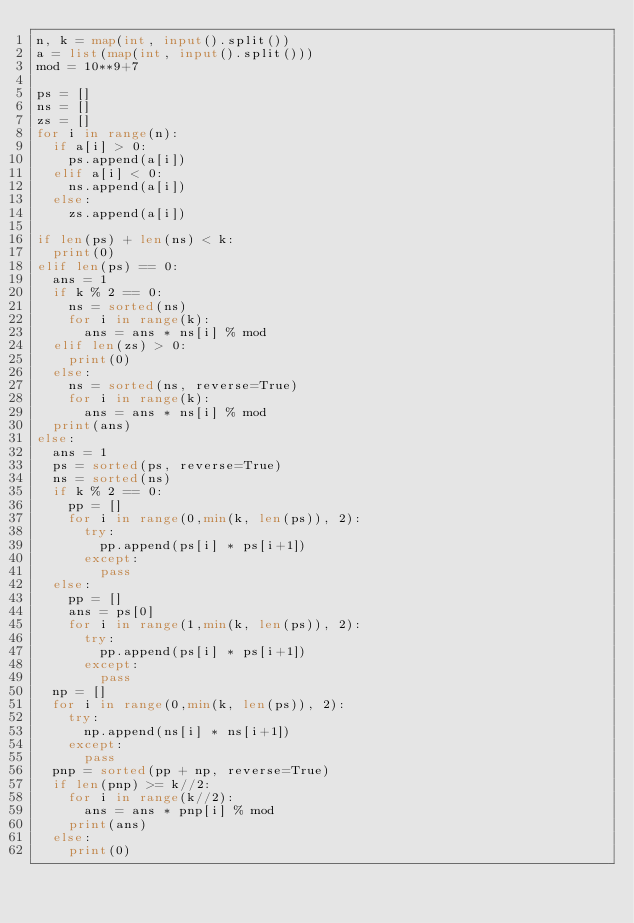Convert code to text. <code><loc_0><loc_0><loc_500><loc_500><_Python_>n, k = map(int, input().split())
a = list(map(int, input().split()))
mod = 10**9+7

ps = []
ns = []
zs = []
for i in range(n):
  if a[i] > 0:
    ps.append(a[i])
  elif a[i] < 0:
    ns.append(a[i])
  else:
    zs.append(a[i])
    
if len(ps) + len(ns) < k:
  print(0)
elif len(ps) == 0:
  ans = 1
  if k % 2 == 0:
    ns = sorted(ns)
    for i in range(k):
      ans = ans * ns[i] % mod
  elif len(zs) > 0:
    print(0)
  else:
    ns = sorted(ns, reverse=True)
    for i in range(k):
      ans = ans * ns[i] % mod
  print(ans)
else:
  ans = 1
  ps = sorted(ps, reverse=True)
  ns = sorted(ns)
  if k % 2 == 0:
    pp = []
    for i in range(0,min(k, len(ps)), 2):
      try:
        pp.append(ps[i] * ps[i+1])
      except:
        pass
  else:
    pp = []
    ans = ps[0]
    for i in range(1,min(k, len(ps)), 2):
      try:
        pp.append(ps[i] * ps[i+1])
      except:
        pass
  np = []
  for i in range(0,min(k, len(ps)), 2):
    try:
      np.append(ns[i] * ns[i+1])
    except:
      pass
  pnp = sorted(pp + np, reverse=True)
  if len(pnp) >= k//2:
    for i in range(k//2):
      ans = ans * pnp[i] % mod
    print(ans)
  else:
    print(0)</code> 